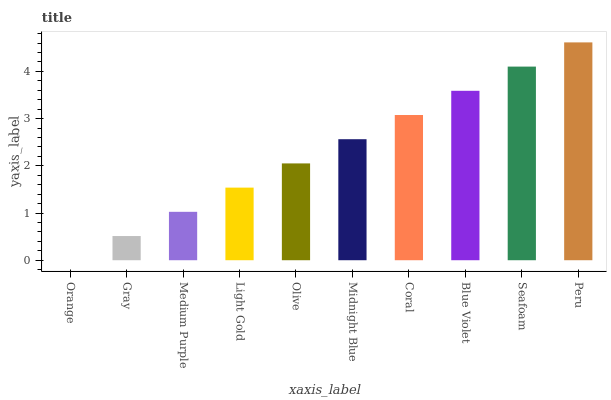Is Gray the minimum?
Answer yes or no. No. Is Gray the maximum?
Answer yes or no. No. Is Gray greater than Orange?
Answer yes or no. Yes. Is Orange less than Gray?
Answer yes or no. Yes. Is Orange greater than Gray?
Answer yes or no. No. Is Gray less than Orange?
Answer yes or no. No. Is Midnight Blue the high median?
Answer yes or no. Yes. Is Olive the low median?
Answer yes or no. Yes. Is Medium Purple the high median?
Answer yes or no. No. Is Blue Violet the low median?
Answer yes or no. No. 